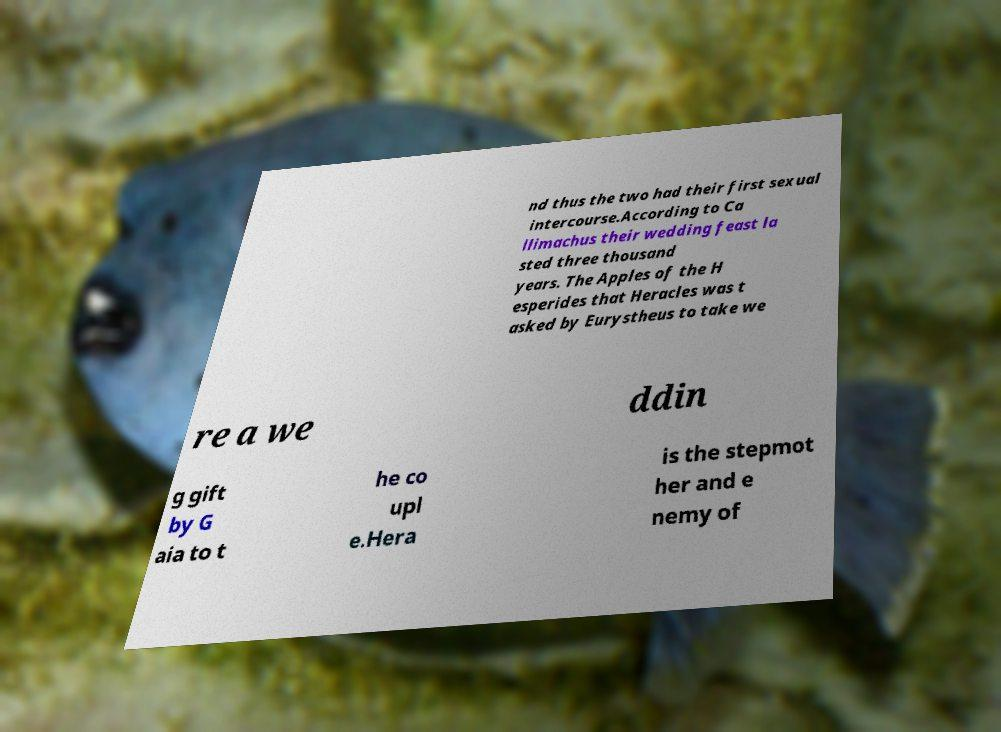Could you extract and type out the text from this image? nd thus the two had their first sexual intercourse.According to Ca llimachus their wedding feast la sted three thousand years. The Apples of the H esperides that Heracles was t asked by Eurystheus to take we re a we ddin g gift by G aia to t he co upl e.Hera is the stepmot her and e nemy of 